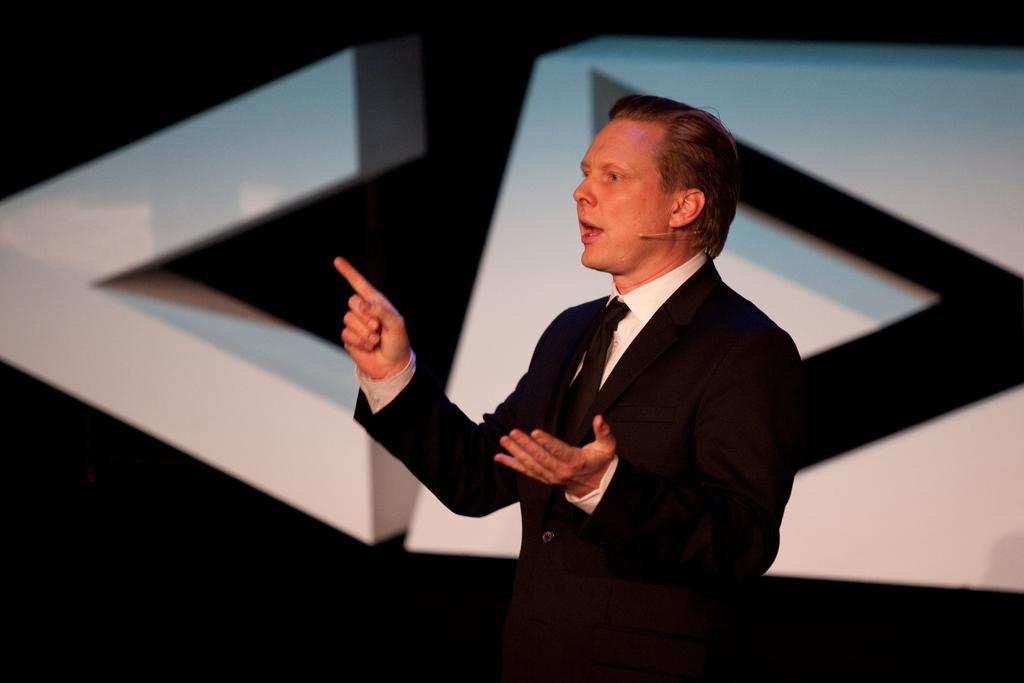Who is in the image? There is a man in the image. What is the man wearing? The man is wearing a black suit. What is the man doing in the image? The man is standing and facing towards the left side, and he is speaking. What can be seen in the background of the image? There are two white blocks in the background of the image. How many giants are visible in the image? There are no giants present in the image. What type of faucet is being used by the man in the image? There is no faucet present in the image, and the man is not using any faucet. 